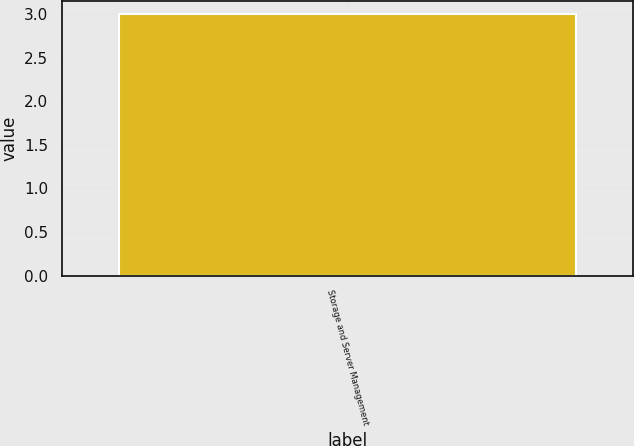Convert chart to OTSL. <chart><loc_0><loc_0><loc_500><loc_500><bar_chart><fcel>Storage and Server Management<nl><fcel>3<nl></chart> 